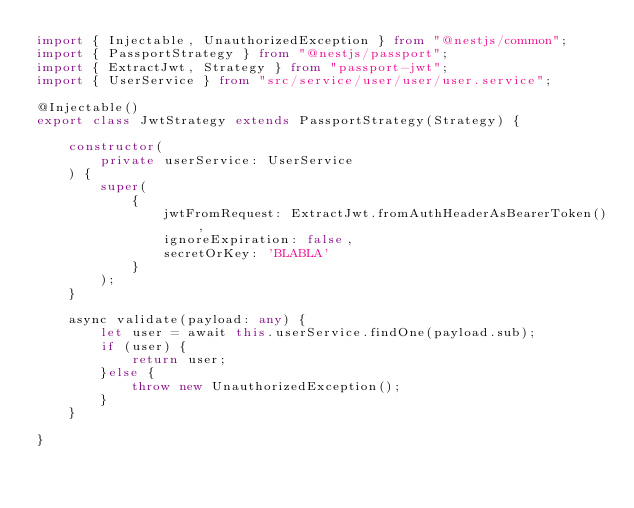<code> <loc_0><loc_0><loc_500><loc_500><_TypeScript_>import { Injectable, UnauthorizedException } from "@nestjs/common";
import { PassportStrategy } from "@nestjs/passport";
import { ExtractJwt, Strategy } from "passport-jwt";
import { UserService } from "src/service/user/user/user.service";

@Injectable()
export class JwtStrategy extends PassportStrategy(Strategy) {

    constructor(
        private userService: UserService
    ) {
        super(
            {
                jwtFromRequest: ExtractJwt.fromAuthHeaderAsBearerToken(),
                ignoreExpiration: false,
                secretOrKey: 'BLABLA'
            }
        );
    }

    async validate(payload: any) {
        let user = await this.userService.findOne(payload.sub);
        if (user) {
            return user;
        }else {
            throw new UnauthorizedException();
        }
    }

}</code> 